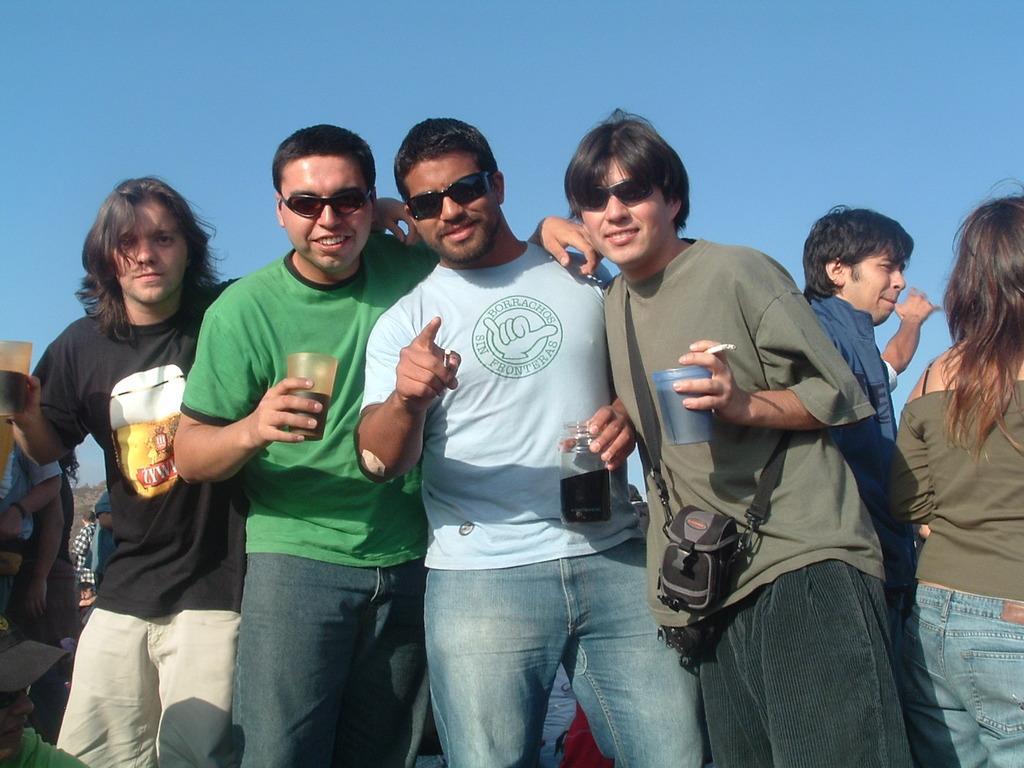In one or two sentences, can you explain what this image depicts? In this image I can see people are standing among them some are holding glasses in hands. These three people are wearing black color shade. In the background I can see the sky. 